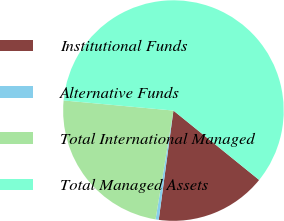Convert chart to OTSL. <chart><loc_0><loc_0><loc_500><loc_500><pie_chart><fcel>Institutional Funds<fcel>Alternative Funds<fcel>Total International Managed<fcel>Total Managed Assets<nl><fcel>16.3%<fcel>0.46%<fcel>23.87%<fcel>59.36%<nl></chart> 